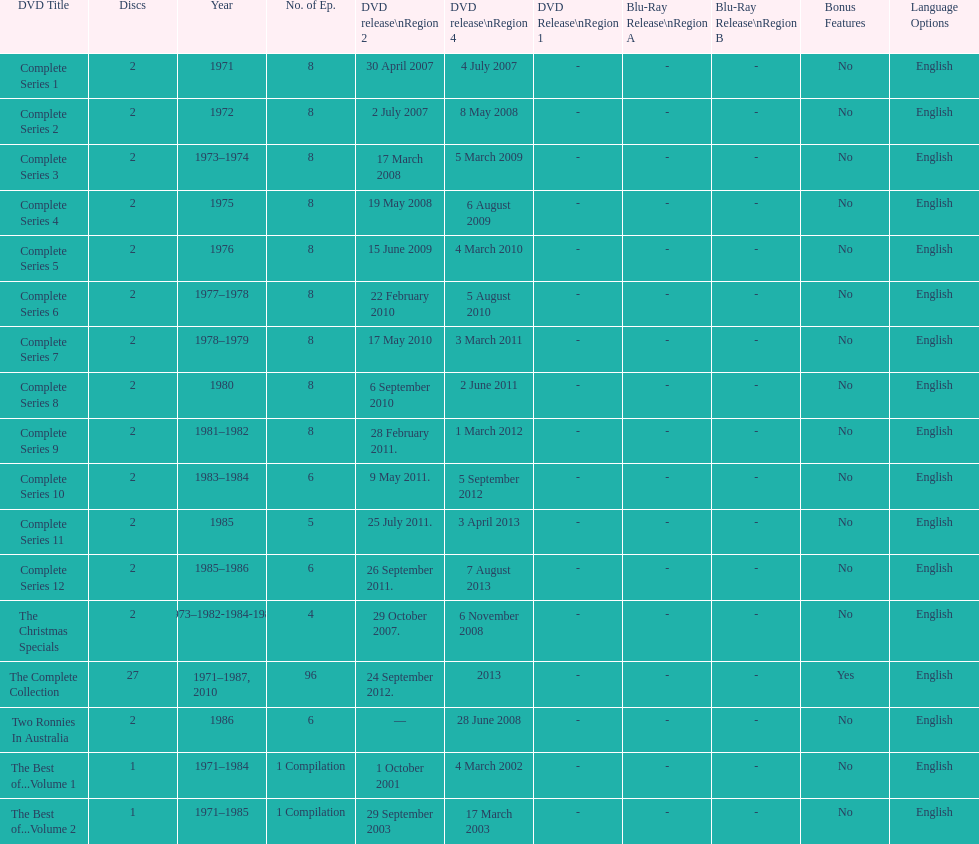With a total of 96 episodes, what quantity of episodes is specifically dedicated to the christmas specials? 4. 